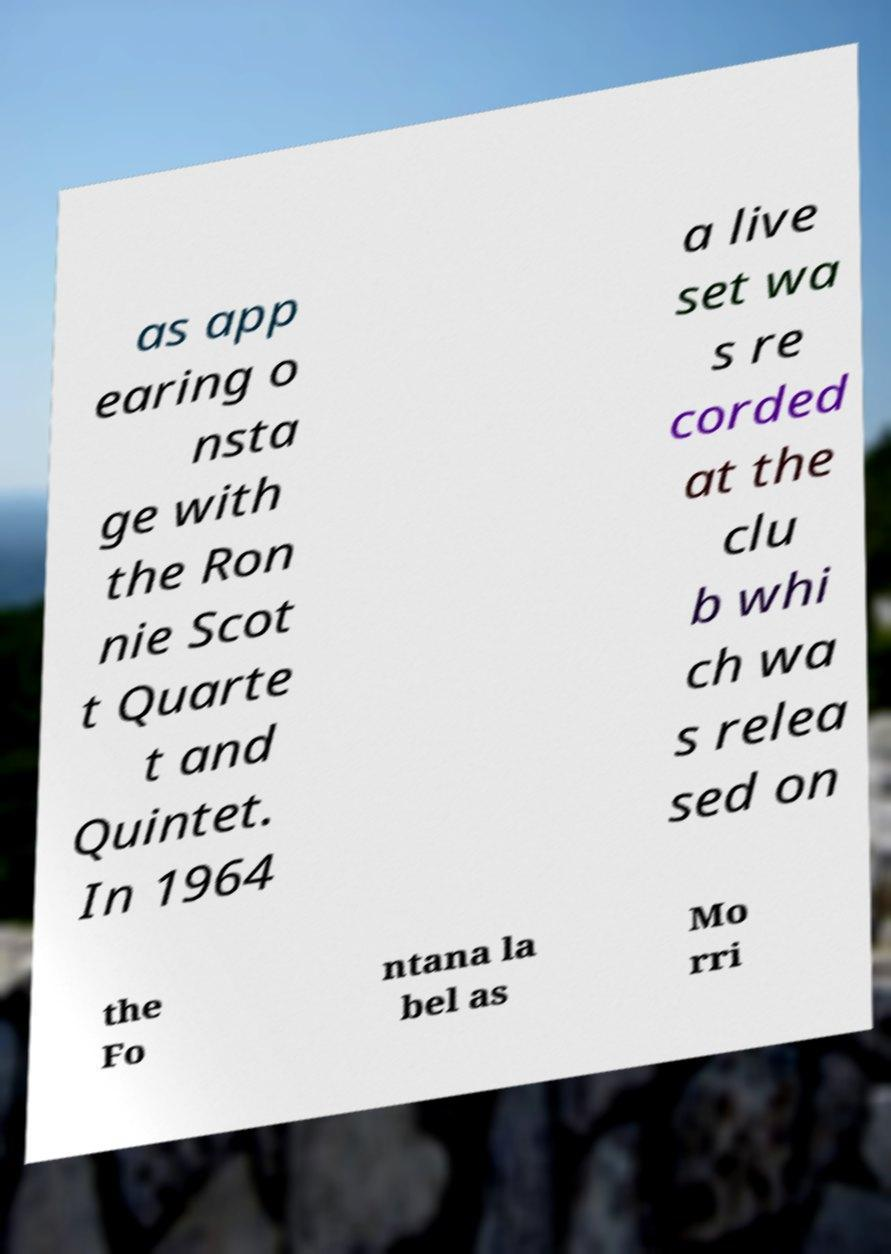Could you extract and type out the text from this image? as app earing o nsta ge with the Ron nie Scot t Quarte t and Quintet. In 1964 a live set wa s re corded at the clu b whi ch wa s relea sed on the Fo ntana la bel as Mo rri 